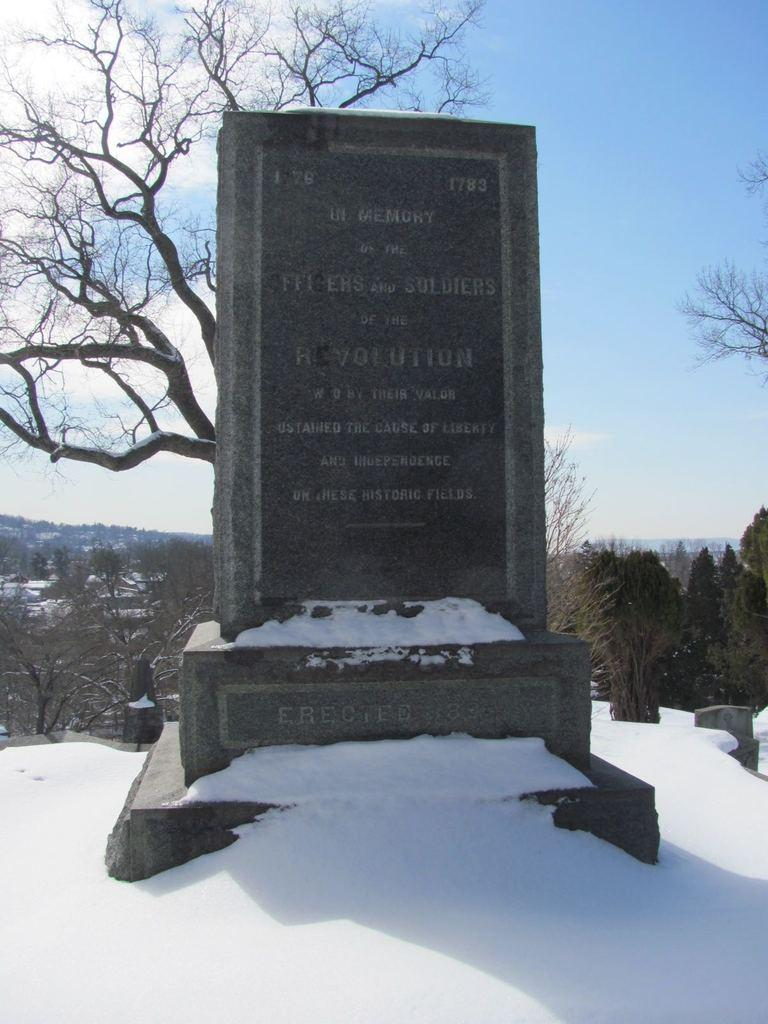What type of vegetation can be seen in the image? There are trees in the image. What is the weather like in the image? There is snow in the image, indicating a cold and likely wintery scene. What man-made structure is present in the image? There is a monument in the image. What colors can be seen in the sky in the image? The sky is a combination of white and blue colors. Can you see a monkey climbing one of the trees in the image? No, there is no monkey present in the image. 